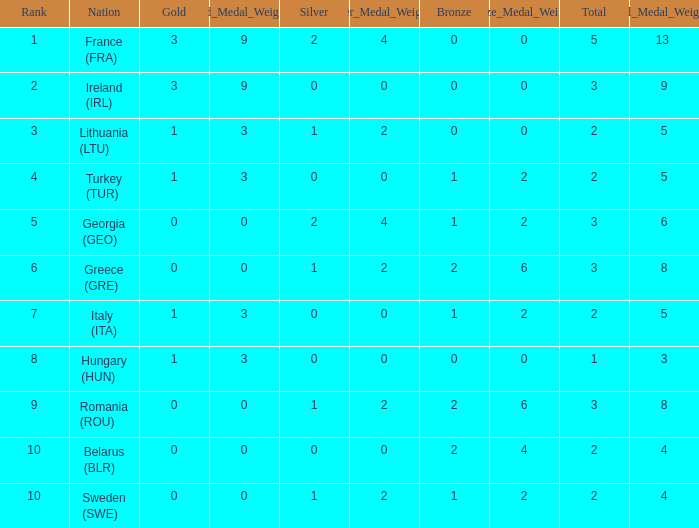What's the total of Sweden (SWE) having less than 1 silver? None. 